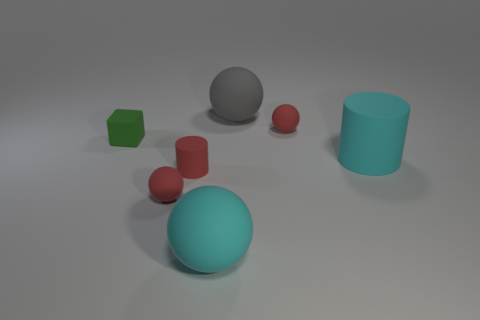Subtract all big cyan rubber spheres. How many spheres are left? 3 Subtract all spheres. How many objects are left? 3 Subtract all red cylinders. How many cylinders are left? 1 Subtract all yellow cylinders. How many red balls are left? 2 Subtract all green objects. Subtract all tiny red cylinders. How many objects are left? 5 Add 7 large cyan cylinders. How many large cyan cylinders are left? 8 Add 6 large gray rubber objects. How many large gray rubber objects exist? 7 Add 1 large gray matte spheres. How many objects exist? 8 Subtract 0 yellow spheres. How many objects are left? 7 Subtract 3 balls. How many balls are left? 1 